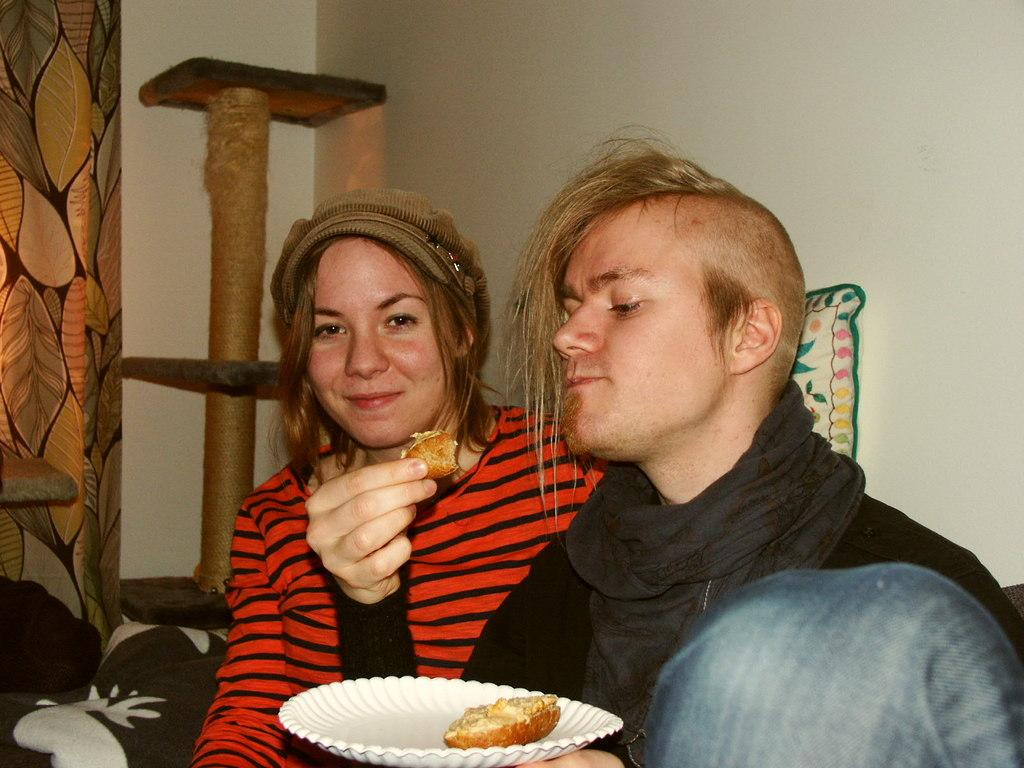What is the person in the image doing? The person is sitting and holding a food item and a plate. Who else is present in the image? There is another person sitting beside the first person. What can be seen in the background of the image? There is a wall poster and a wall in the image. What items are related to clothing in the image? Clothes are present in the image. How does the person in the image make a payment for the food item? There is no information about payment in the image, as it only shows a person holding a food item and a plate. 